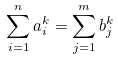<formula> <loc_0><loc_0><loc_500><loc_500>\sum _ { i = 1 } ^ { n } a _ { i } ^ { k } = \sum _ { j = 1 } ^ { m } b _ { j } ^ { k }</formula> 